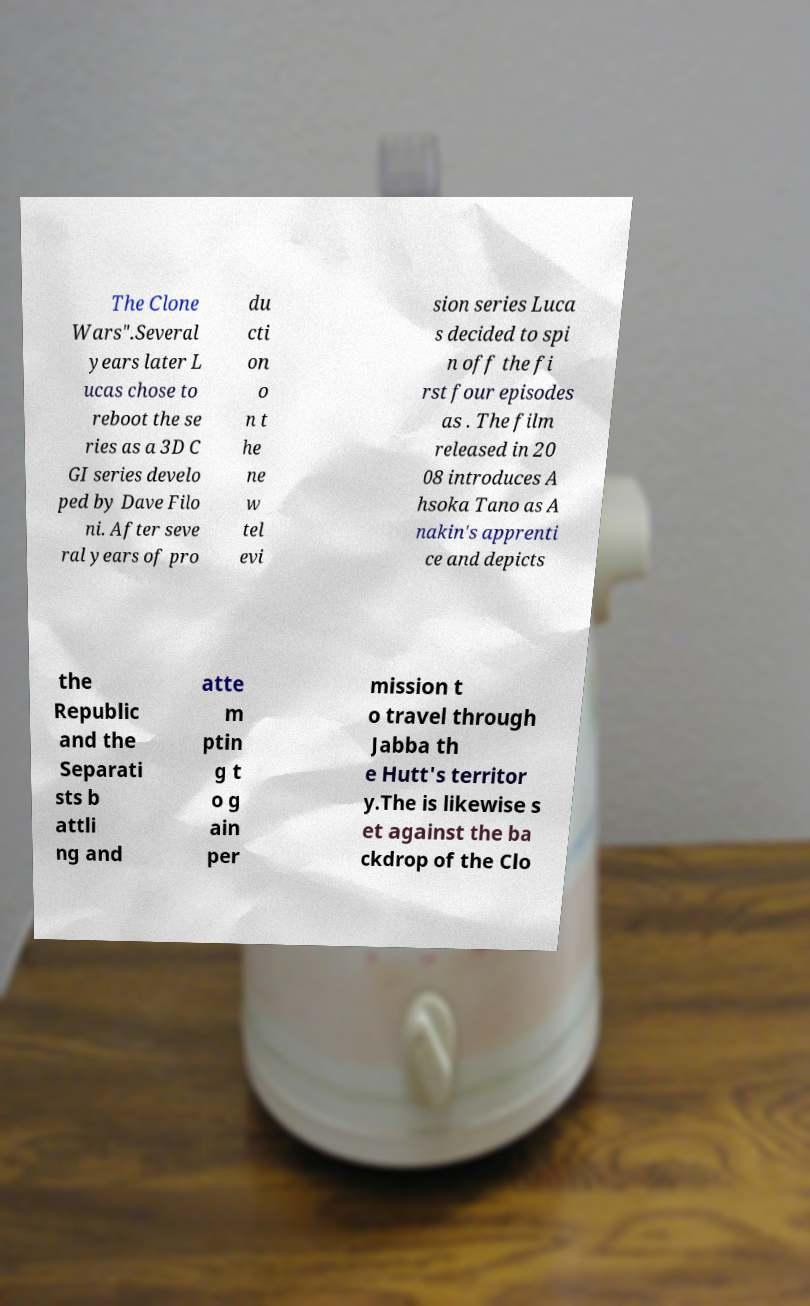Could you assist in decoding the text presented in this image and type it out clearly? The Clone Wars".Several years later L ucas chose to reboot the se ries as a 3D C GI series develo ped by Dave Filo ni. After seve ral years of pro du cti on o n t he ne w tel evi sion series Luca s decided to spi n off the fi rst four episodes as . The film released in 20 08 introduces A hsoka Tano as A nakin's apprenti ce and depicts the Republic and the Separati sts b attli ng and atte m ptin g t o g ain per mission t o travel through Jabba th e Hutt's territor y.The is likewise s et against the ba ckdrop of the Clo 